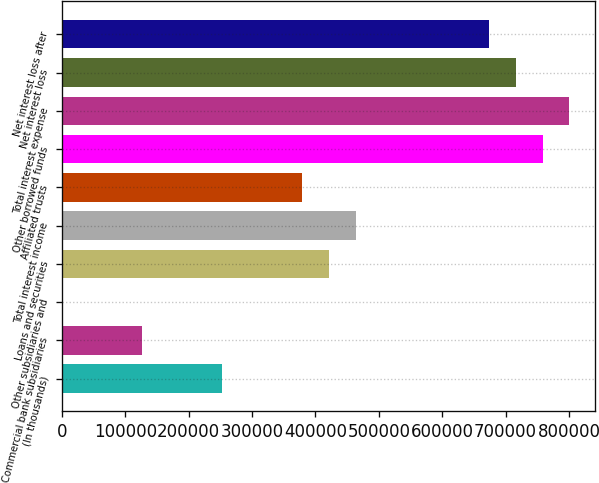Convert chart. <chart><loc_0><loc_0><loc_500><loc_500><bar_chart><fcel>(In thousands)<fcel>Commercial bank subsidiaries<fcel>Other subsidiaries and<fcel>Loans and securities<fcel>Total interest income<fcel>Affiliated trusts<fcel>Other borrowed funds<fcel>Total interest expense<fcel>Net interest loss<fcel>Net interest loss after<nl><fcel>252886<fcel>126495<fcel>105<fcel>421406<fcel>463536<fcel>379276<fcel>758447<fcel>800577<fcel>716317<fcel>674187<nl></chart> 